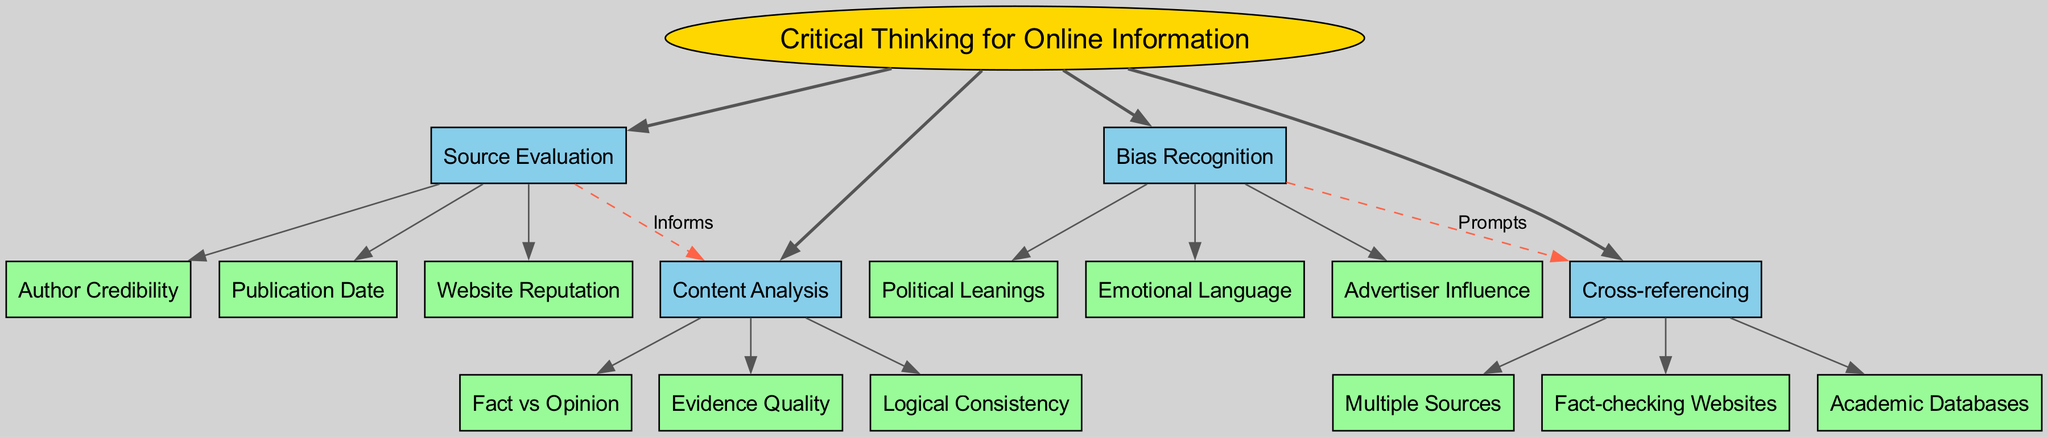What is the central concept of this diagram? The central concept is clearly labeled in a prominent position at the top of the diagram, which states "Critical Thinking for Online Information."
Answer: Critical Thinking for Online Information How many main branches are represented in the diagram? By examining the structure of the diagram, we can see there are a total of four main branches extending from the central concept.
Answer: 4 What does the "Source Evaluation" branch inform? The diagram shows a dashed connection between "Source Evaluation" and "Content Analysis," indicating that "Source Evaluation" informs "Content Analysis."
Answer: Content Analysis Name one sub-branch under "Bias Recognition." There are three sub-branches listed under "Bias Recognition," and one of them is "Political Leanings." This can be easily identified by examining the branch itself.
Answer: Political Leanings What prompts the need for "Cross-referencing"? The diagram illustrates that "Bias Recognition" prompts "Cross-referencing," as indicated by the labeled dashed line connecting these two branches.
Answer: Cross-referencing How many connections exist between the main branches? Upon reviewing the connections indicated in the diagram, there are two connections shown between the main branches.
Answer: 2 What is one method of "Cross-referencing"? When looking under the "Cross-referencing" branch, one method is "Fact-checking Websites," which is specifically listed as a sub-branch.
Answer: Fact-checking Websites Which branch directly evaluates "Author Credibility"? The branch that directly evaluates "Author Credibility" is "Source Evaluation," as indicated by its sub-branch components.
Answer: Source Evaluation What type of language should be recognized under "Bias Recognition"? The sub-branch "Emotional Language" specifically addresses the type of language to be recognized under "Bias Recognition."
Answer: Emotional Language 